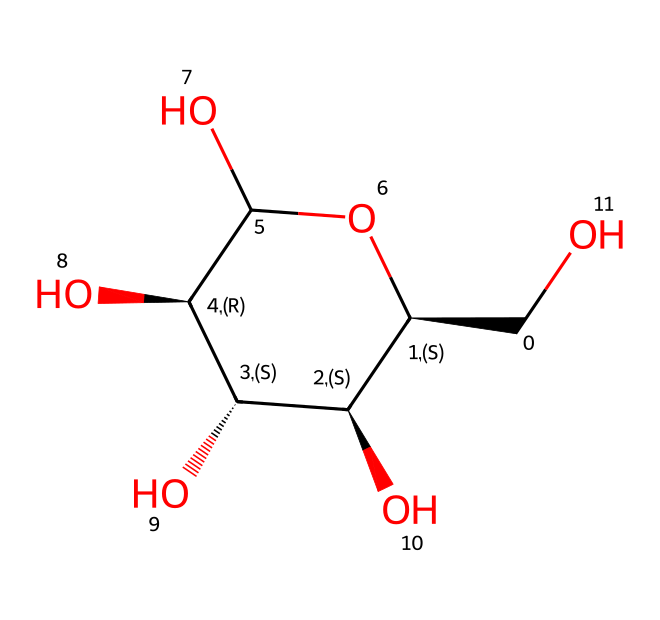How many carbon atoms are in this molecule? By analyzing the SMILES representation, one can count the number of carbon (C) symbols, which represent the carbon atoms in the structure. In this case, there are six carbon atoms present.
Answer: six What type of carbohydrate is represented by this structure? The structure is indicative of cellulose, a polysaccharide made of linear chains of glucose units, characterized by its role in plant cell walls.
Answer: cellulose How many hydroxyl (–OH) groups are present in this structure? The –OH groups are represented in the SMILES by the 'O' connected to 'C' and then to hydrogen (H). By examining the structure, we identify four hydroxyl groups attached to various carbon atoms.
Answer: four What is the degree of polymerization of this carbohydrate? The degree of polymerization for cellulose can be inferred from the number of repeating units in the structure. In this case, the representation indicates a chain of three glucose units, leading to a degree of polymerization of three.
Answer: three How many total oxygen atoms are found in this molecule? Counting the number of 'O' in the SMILES provides the total count of oxygen atoms. There are five oxygen atoms present in the structure of this cellulose molecule.
Answer: five What is the molecular weight of cellulose represented by this structure? The molecular weight can be calculated by summing the atomic weights of all the atoms represented in the structure based on counts of the atoms (in particular, carbon, hydrogen, and oxygen). The total molecular weight for the specified structure is about 162 grams per mole.
Answer: one hundred sixty-two 